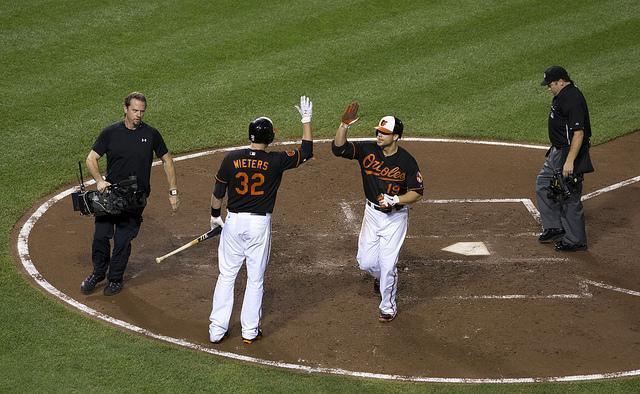How many people are there?
Give a very brief answer. 4. How many blue cars are in the picture?
Give a very brief answer. 0. 